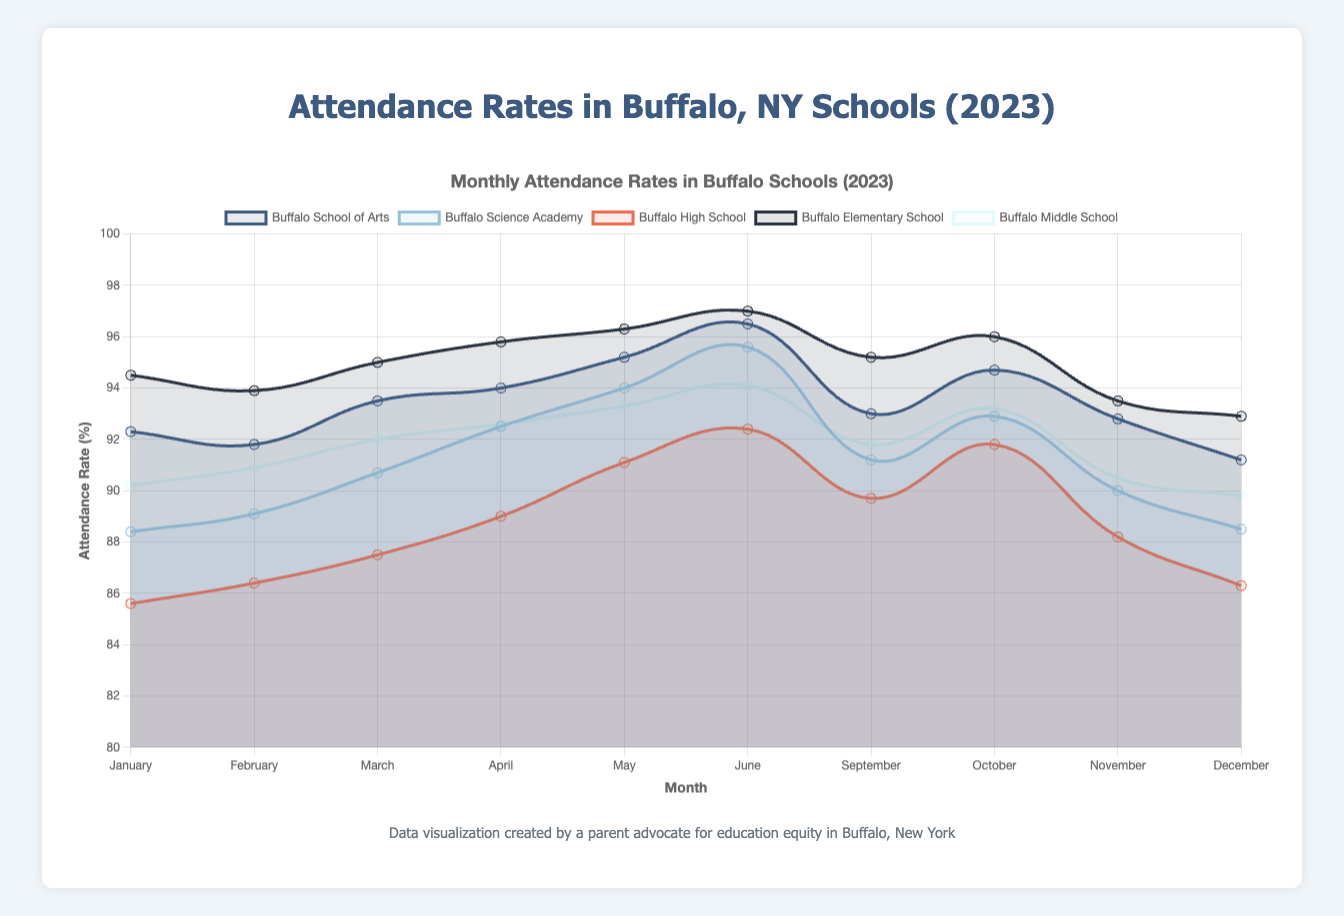Which school had the highest attendance rate in June? To determine this, refer to the dataset and identify the highest attendance rate in June. The attendance rates in June are 96.5% (Buffalo School of Arts), 95.6% (Buffalo Science Academy), 92.4% (Buffalo High School), 97.0% (Buffalo Elementary School), and 94.1% (Buffalo Middle School). Buffalo Elementary School has the highest attendance rate.
Answer: Buffalo Elementary School What is the average attendance rate for Buffalo High School from January to June? Calculate the average by summing the attendance rates from January to June and dividing by the number of months. The rates are January: 85.6, February: 86.4, March: 87.5, April: 89.0, May: 91.1, June: 92.4. Sum = 532.0. Average = 532.0 / 6 = 88.67
Answer: 88.67 Which months did Buffalo Middle School have the lowest attendance rate? Look at the attendance rates for Buffalo Middle School for all the months provided. The rates are: January: 90.2, February: 90.9, March: 92.0, April: 92.6, May: 93.3, June: 94.1, September: 91.8, October: 93.2, November: 90.5, December: 89.8. The lowest attendance rate is in December.
Answer: December Compare the difference in attendance rates between February and May for Buffalo Science Academy. Subtract the attendance rate in February from the rate in May for Buffalo Science Academy. The rates are February: 89.1%, May: 94.0%. Difference = 94.0 - 89.1 = 4.9
Answer: 4.9 Which school showed the most improvement in attendance rate from January to June? Calculate the difference between the two months' attendance rates for each school and determine the school with the highest increase. Buffalo School of Arts: (96.5 - 92.3) = 4.2, Buffalo Science Academy: (95.6 - 88.4) = 7.2, Buffalo High School: (92.4 - 85.6) = 6.8, Buffalo Elementary School: (97.0 - 94.5) = 2.5, Buffalo Middle School: (94.1 - 90.2) = 3.9. Buffalo Science Academy has the highest improvement.
Answer: Buffalo Science Academy 